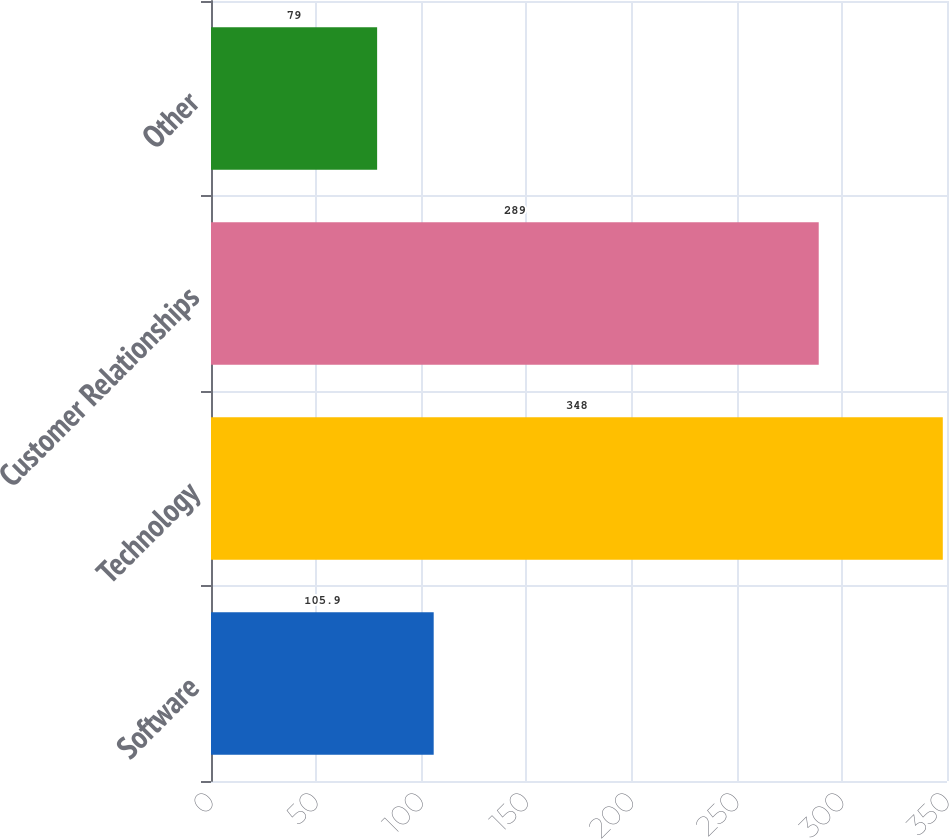Convert chart. <chart><loc_0><loc_0><loc_500><loc_500><bar_chart><fcel>Software<fcel>Technology<fcel>Customer Relationships<fcel>Other<nl><fcel>105.9<fcel>348<fcel>289<fcel>79<nl></chart> 